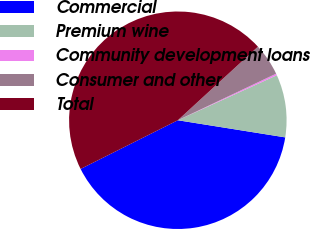<chart> <loc_0><loc_0><loc_500><loc_500><pie_chart><fcel>Commercial<fcel>Premium wine<fcel>Community development loans<fcel>Consumer and other<fcel>Total<nl><fcel>40.09%<fcel>9.31%<fcel>0.25%<fcel>4.78%<fcel>45.56%<nl></chart> 